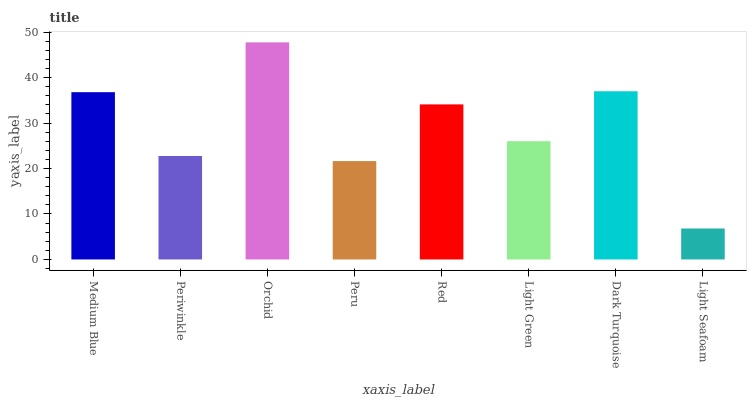Is Periwinkle the minimum?
Answer yes or no. No. Is Periwinkle the maximum?
Answer yes or no. No. Is Medium Blue greater than Periwinkle?
Answer yes or no. Yes. Is Periwinkle less than Medium Blue?
Answer yes or no. Yes. Is Periwinkle greater than Medium Blue?
Answer yes or no. No. Is Medium Blue less than Periwinkle?
Answer yes or no. No. Is Red the high median?
Answer yes or no. Yes. Is Light Green the low median?
Answer yes or no. Yes. Is Light Green the high median?
Answer yes or no. No. Is Peru the low median?
Answer yes or no. No. 